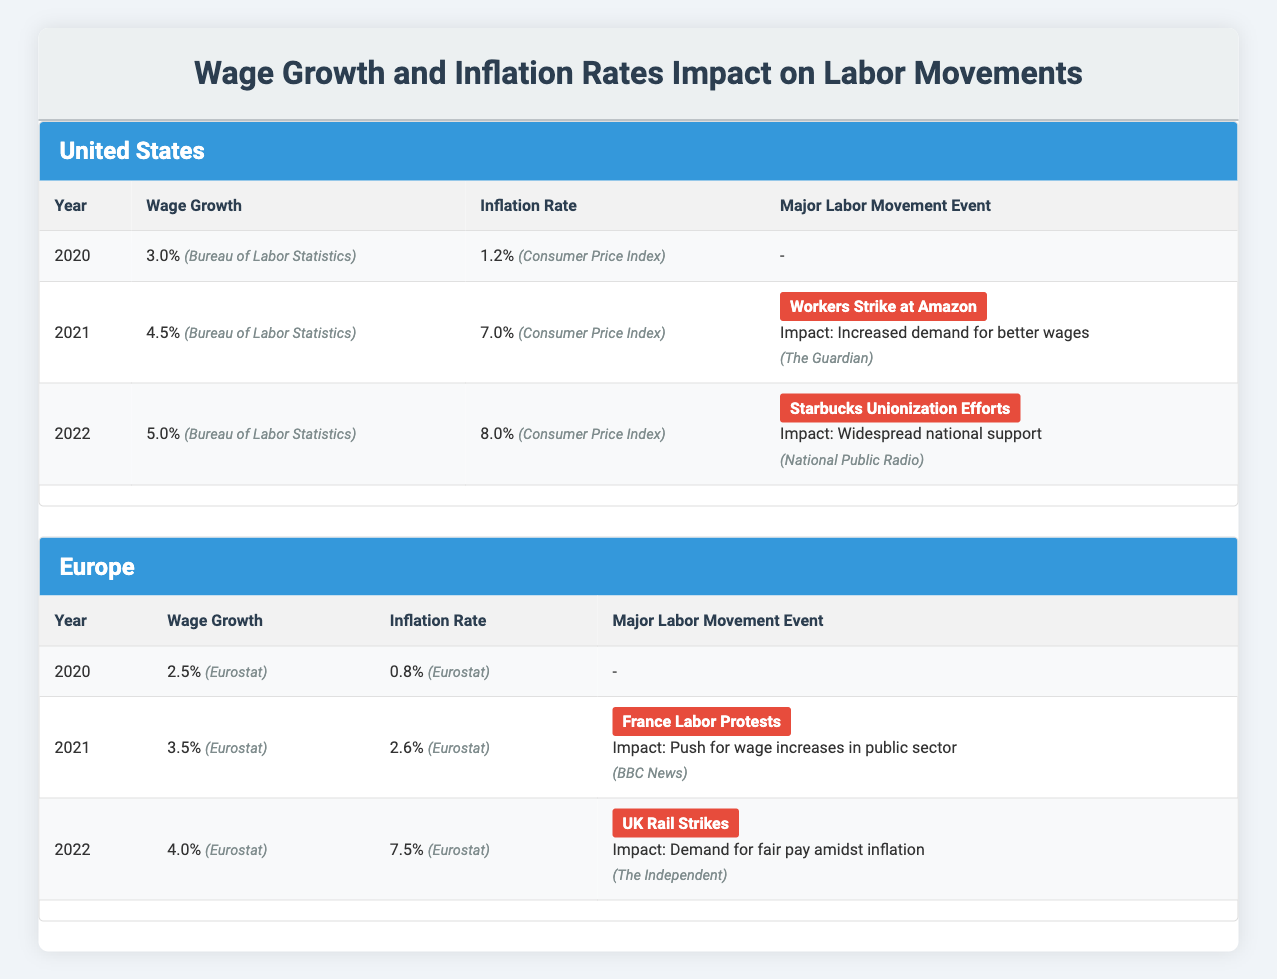What is the wage growth percentage in the United States for 2022? According to the table, the wage growth percentage for the United States in 2022 is directly listed as 5.0% under the Wage Growth category.
Answer: 5.0% What was the inflation rate in Europe for 2021? The table shows that the inflation rate in Europe for 2021 is stated as 2.6%.
Answer: 2.6% Which major labor movement event occurred in the United States in 2021? The table indicates that in 2021, the major labor movement event in the United States was the Workers Strike at Amazon.
Answer: Workers Strike at Amazon What is the difference in wage growth between the United States and Europe for the year 2022? For the year 2022, the United States has a wage growth of 5.0%, while Europe has a wage growth of 4.0%. Therefore, the difference is 5.0% - 4.0% = 1.0%.
Answer: 1.0% Is the inflation rate in the United States higher than in Europe for the year 2022? Checking the table, the inflation rate in the United States for 2022 is 8.0%, while Europe’s rate is 7.5%. Since 8.0% is greater than 7.5%, the answer is true.
Answer: Yes What was the average wage growth in the United States from 2020 to 2022? The wage growth percentages for the United States from 2020 to 2022 are 3.0%, 4.5%, and 5.0%. By summing these values: 3.0 + 4.5 + 5.0 = 12.5 and then dividing by 3 gives an average of 12.5 / 3 = 4.1667%, which rounds to 4.17%.
Answer: 4.17% What is the inflation rate trend in Europe from 2020 to 2022? Looking at the inflation rates for Europe from 2020 to 2022: 0.8% in 2020, 2.6% in 2021, and 7.5% in 2022 shows a clear upward trend, growing from 0.8% to 7.5%.
Answer: Upward trend What labor movement event in 2022 had a significant impact in the United States? The table notes that in 2022, the Starbucks Unionization Efforts occurred, which had a widespread national support impact.
Answer: Starbucks Unionization Efforts Was there a labor movement event in Europe in 2020? The table lists no major labor movement events for Europe in 2020, indicated by a dash (-) under that row. Hence, the statement is false.
Answer: No 